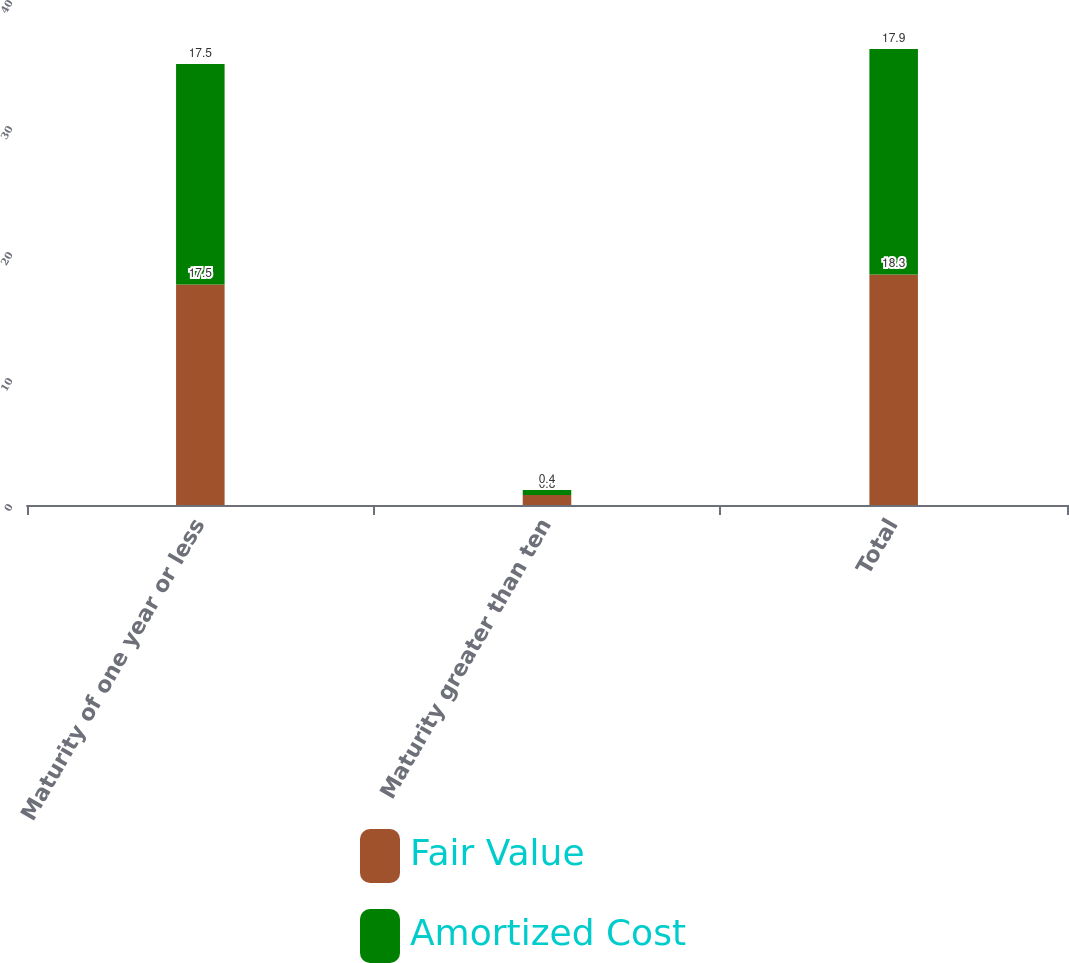Convert chart. <chart><loc_0><loc_0><loc_500><loc_500><stacked_bar_chart><ecel><fcel>Maturity of one year or less<fcel>Maturity greater than ten<fcel>Total<nl><fcel>Fair Value<fcel>17.5<fcel>0.8<fcel>18.3<nl><fcel>Amortized Cost<fcel>17.5<fcel>0.4<fcel>17.9<nl></chart> 